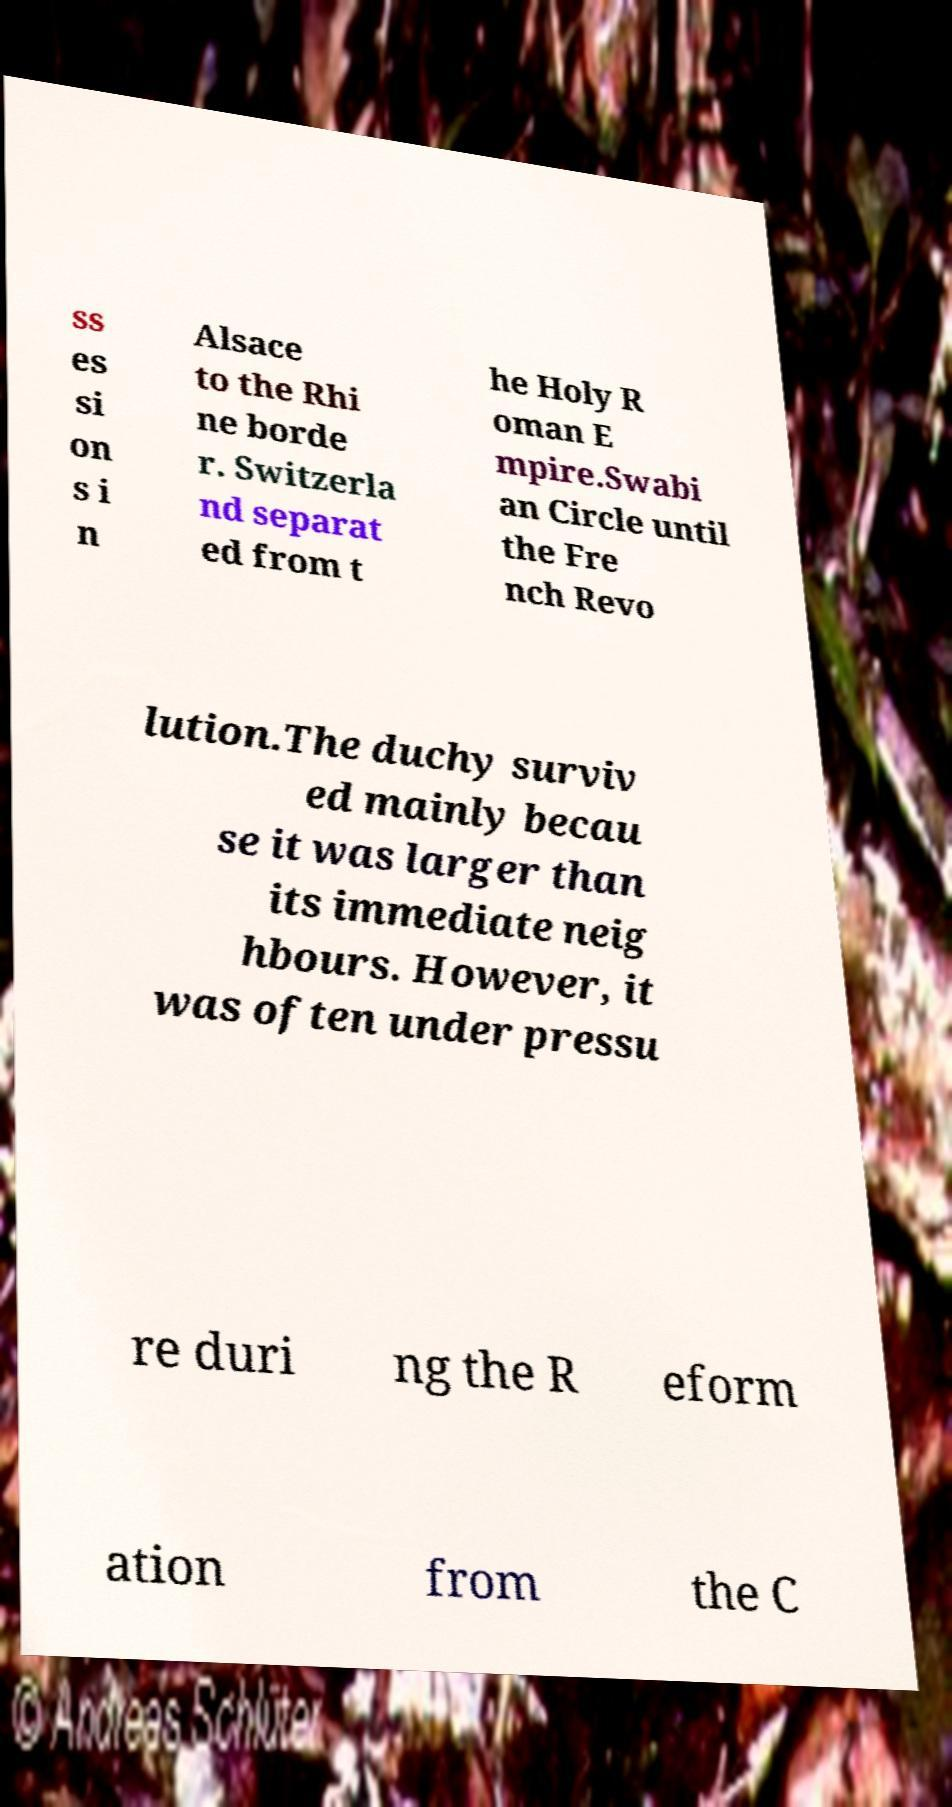Could you extract and type out the text from this image? ss es si on s i n Alsace to the Rhi ne borde r. Switzerla nd separat ed from t he Holy R oman E mpire.Swabi an Circle until the Fre nch Revo lution.The duchy surviv ed mainly becau se it was larger than its immediate neig hbours. However, it was often under pressu re duri ng the R eform ation from the C 